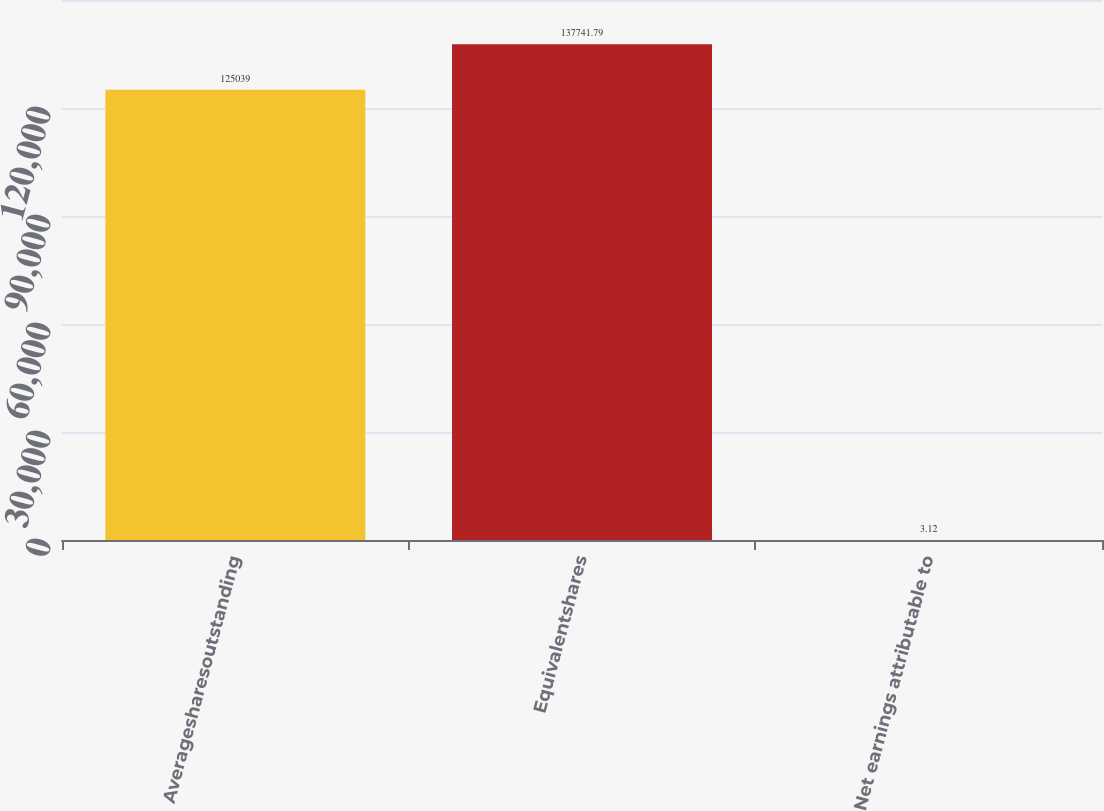Convert chart. <chart><loc_0><loc_0><loc_500><loc_500><bar_chart><fcel>Averagesharesoutstanding<fcel>Equivalentshares<fcel>Net earnings attributable to<nl><fcel>125039<fcel>137742<fcel>3.12<nl></chart> 